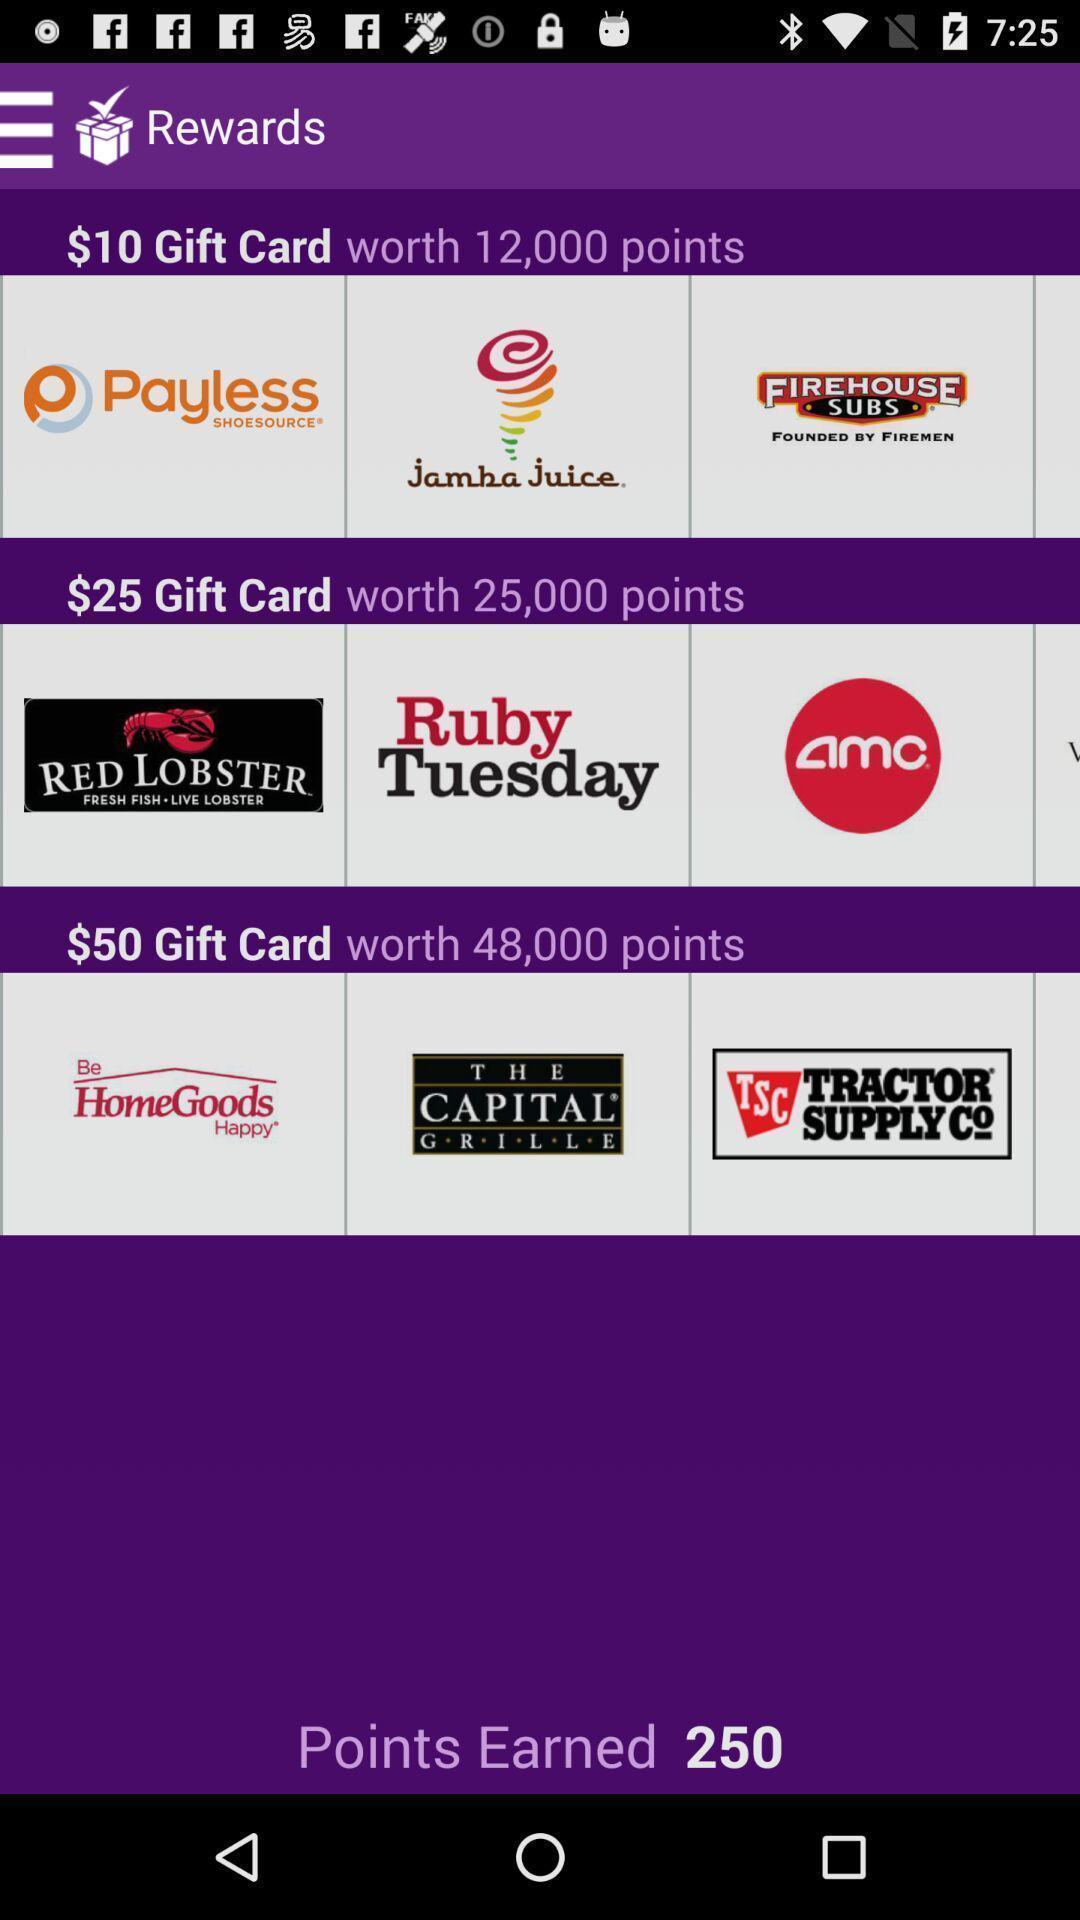What can you discern from this picture? Page displaying with different gift cards. 